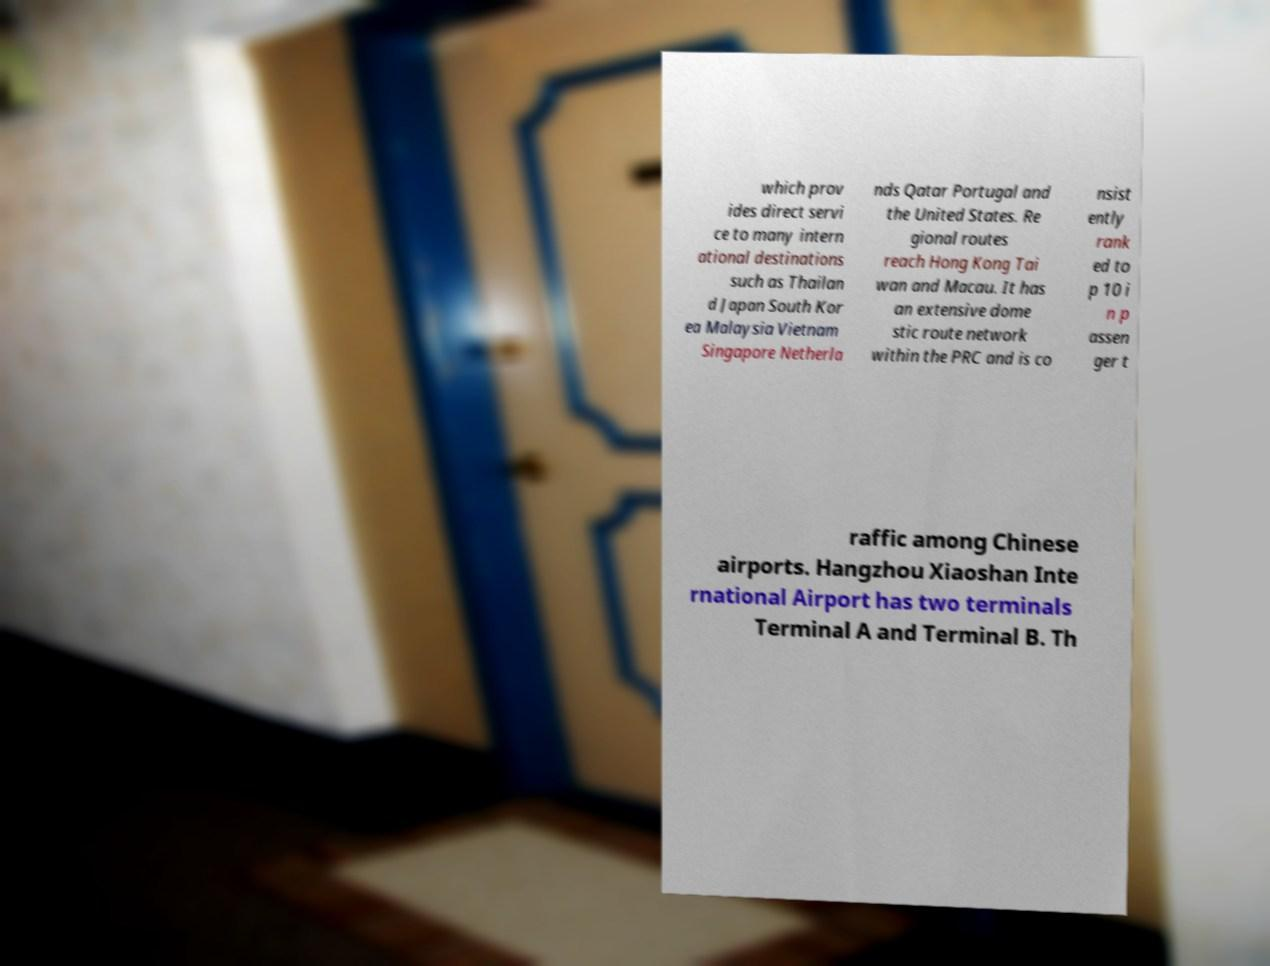Please identify and transcribe the text found in this image. which prov ides direct servi ce to many intern ational destinations such as Thailan d Japan South Kor ea Malaysia Vietnam Singapore Netherla nds Qatar Portugal and the United States. Re gional routes reach Hong Kong Tai wan and Macau. It has an extensive dome stic route network within the PRC and is co nsist ently rank ed to p 10 i n p assen ger t raffic among Chinese airports. Hangzhou Xiaoshan Inte rnational Airport has two terminals Terminal A and Terminal B. Th 